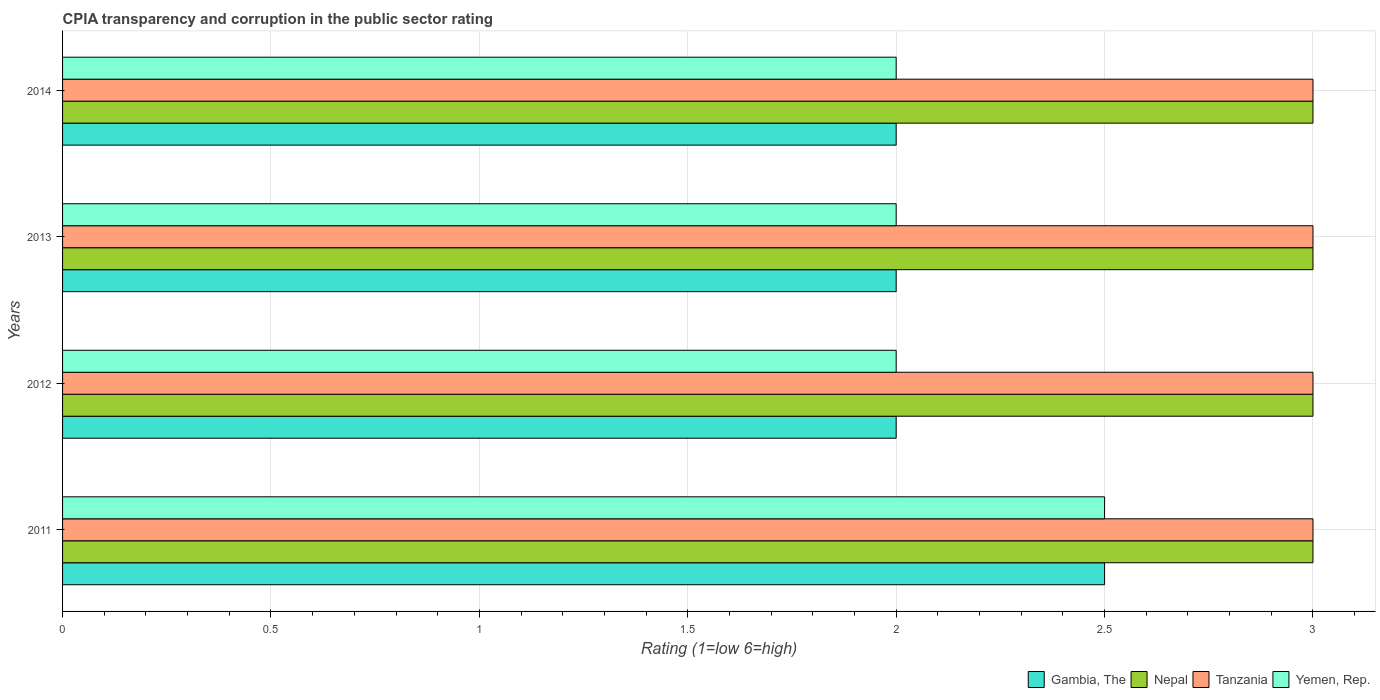How many different coloured bars are there?
Your answer should be compact. 4. Are the number of bars per tick equal to the number of legend labels?
Your answer should be very brief. Yes. How many bars are there on the 3rd tick from the bottom?
Your response must be concise. 4. What is the label of the 2nd group of bars from the top?
Make the answer very short. 2013. In how many cases, is the number of bars for a given year not equal to the number of legend labels?
Offer a terse response. 0. What is the CPIA rating in Yemen, Rep. in 2011?
Ensure brevity in your answer.  2.5. Across all years, what is the maximum CPIA rating in Gambia, The?
Offer a terse response. 2.5. Across all years, what is the minimum CPIA rating in Yemen, Rep.?
Make the answer very short. 2. In which year was the CPIA rating in Gambia, The maximum?
Offer a terse response. 2011. What is the total CPIA rating in Gambia, The in the graph?
Give a very brief answer. 8.5. What is the difference between the CPIA rating in Yemen, Rep. in 2013 and that in 2014?
Provide a short and direct response. 0. What is the difference between the CPIA rating in Yemen, Rep. in 2011 and the CPIA rating in Nepal in 2014?
Provide a succinct answer. -0.5. What is the average CPIA rating in Yemen, Rep. per year?
Your response must be concise. 2.12. In the year 2013, what is the difference between the CPIA rating in Tanzania and CPIA rating in Gambia, The?
Offer a very short reply. 1. What is the difference between the highest and the lowest CPIA rating in Gambia, The?
Make the answer very short. 0.5. Is the sum of the CPIA rating in Gambia, The in 2011 and 2012 greater than the maximum CPIA rating in Tanzania across all years?
Provide a short and direct response. Yes. Is it the case that in every year, the sum of the CPIA rating in Gambia, The and CPIA rating in Yemen, Rep. is greater than the sum of CPIA rating in Nepal and CPIA rating in Tanzania?
Keep it short and to the point. No. What does the 2nd bar from the top in 2011 represents?
Your response must be concise. Tanzania. What does the 4th bar from the bottom in 2013 represents?
Offer a terse response. Yemen, Rep. Are all the bars in the graph horizontal?
Keep it short and to the point. Yes. Does the graph contain any zero values?
Keep it short and to the point. No. Does the graph contain grids?
Make the answer very short. Yes. Where does the legend appear in the graph?
Offer a very short reply. Bottom right. How are the legend labels stacked?
Offer a terse response. Horizontal. What is the title of the graph?
Ensure brevity in your answer.  CPIA transparency and corruption in the public sector rating. What is the label or title of the X-axis?
Offer a terse response. Rating (1=low 6=high). What is the label or title of the Y-axis?
Keep it short and to the point. Years. What is the Rating (1=low 6=high) of Tanzania in 2011?
Your answer should be very brief. 3. What is the Rating (1=low 6=high) in Yemen, Rep. in 2011?
Your answer should be very brief. 2.5. What is the Rating (1=low 6=high) in Tanzania in 2012?
Your response must be concise. 3. What is the Rating (1=low 6=high) of Gambia, The in 2013?
Your response must be concise. 2. What is the Rating (1=low 6=high) of Nepal in 2013?
Your answer should be compact. 3. What is the Rating (1=low 6=high) in Tanzania in 2013?
Offer a terse response. 3. What is the Rating (1=low 6=high) in Yemen, Rep. in 2013?
Give a very brief answer. 2. What is the Rating (1=low 6=high) of Gambia, The in 2014?
Keep it short and to the point. 2. What is the Rating (1=low 6=high) of Nepal in 2014?
Keep it short and to the point. 3. What is the Rating (1=low 6=high) of Yemen, Rep. in 2014?
Make the answer very short. 2. Across all years, what is the maximum Rating (1=low 6=high) in Gambia, The?
Make the answer very short. 2.5. Across all years, what is the maximum Rating (1=low 6=high) in Tanzania?
Offer a very short reply. 3. Across all years, what is the minimum Rating (1=low 6=high) in Gambia, The?
Your response must be concise. 2. Across all years, what is the minimum Rating (1=low 6=high) in Nepal?
Your answer should be compact. 3. What is the total Rating (1=low 6=high) in Nepal in the graph?
Offer a very short reply. 12. What is the total Rating (1=low 6=high) of Tanzania in the graph?
Provide a succinct answer. 12. What is the total Rating (1=low 6=high) in Yemen, Rep. in the graph?
Provide a short and direct response. 8.5. What is the difference between the Rating (1=low 6=high) of Gambia, The in 2011 and that in 2012?
Provide a short and direct response. 0.5. What is the difference between the Rating (1=low 6=high) of Nepal in 2011 and that in 2012?
Make the answer very short. 0. What is the difference between the Rating (1=low 6=high) of Tanzania in 2011 and that in 2012?
Your response must be concise. 0. What is the difference between the Rating (1=low 6=high) of Nepal in 2011 and that in 2013?
Make the answer very short. 0. What is the difference between the Rating (1=low 6=high) in Tanzania in 2011 and that in 2014?
Offer a very short reply. 0. What is the difference between the Rating (1=low 6=high) in Gambia, The in 2012 and that in 2013?
Offer a terse response. 0. What is the difference between the Rating (1=low 6=high) in Gambia, The in 2012 and that in 2014?
Your answer should be compact. 0. What is the difference between the Rating (1=low 6=high) of Nepal in 2012 and that in 2014?
Make the answer very short. 0. What is the difference between the Rating (1=low 6=high) of Yemen, Rep. in 2012 and that in 2014?
Ensure brevity in your answer.  0. What is the difference between the Rating (1=low 6=high) of Gambia, The in 2011 and the Rating (1=low 6=high) of Yemen, Rep. in 2012?
Provide a short and direct response. 0.5. What is the difference between the Rating (1=low 6=high) in Nepal in 2011 and the Rating (1=low 6=high) in Yemen, Rep. in 2012?
Your response must be concise. 1. What is the difference between the Rating (1=low 6=high) of Tanzania in 2011 and the Rating (1=low 6=high) of Yemen, Rep. in 2012?
Offer a terse response. 1. What is the difference between the Rating (1=low 6=high) of Gambia, The in 2011 and the Rating (1=low 6=high) of Nepal in 2013?
Offer a terse response. -0.5. What is the difference between the Rating (1=low 6=high) in Gambia, The in 2011 and the Rating (1=low 6=high) in Yemen, Rep. in 2013?
Ensure brevity in your answer.  0.5. What is the difference between the Rating (1=low 6=high) in Gambia, The in 2011 and the Rating (1=low 6=high) in Tanzania in 2014?
Make the answer very short. -0.5. What is the difference between the Rating (1=low 6=high) in Gambia, The in 2011 and the Rating (1=low 6=high) in Yemen, Rep. in 2014?
Offer a terse response. 0.5. What is the difference between the Rating (1=low 6=high) of Tanzania in 2011 and the Rating (1=low 6=high) of Yemen, Rep. in 2014?
Keep it short and to the point. 1. What is the difference between the Rating (1=low 6=high) in Gambia, The in 2012 and the Rating (1=low 6=high) in Yemen, Rep. in 2013?
Offer a terse response. 0. What is the difference between the Rating (1=low 6=high) of Nepal in 2012 and the Rating (1=low 6=high) of Tanzania in 2013?
Make the answer very short. 0. What is the difference between the Rating (1=low 6=high) of Nepal in 2012 and the Rating (1=low 6=high) of Yemen, Rep. in 2013?
Your response must be concise. 1. What is the difference between the Rating (1=low 6=high) of Gambia, The in 2012 and the Rating (1=low 6=high) of Nepal in 2014?
Make the answer very short. -1. What is the difference between the Rating (1=low 6=high) of Gambia, The in 2012 and the Rating (1=low 6=high) of Tanzania in 2014?
Ensure brevity in your answer.  -1. What is the difference between the Rating (1=low 6=high) in Tanzania in 2012 and the Rating (1=low 6=high) in Yemen, Rep. in 2014?
Keep it short and to the point. 1. What is the difference between the Rating (1=low 6=high) in Gambia, The in 2013 and the Rating (1=low 6=high) in Nepal in 2014?
Your response must be concise. -1. What is the average Rating (1=low 6=high) in Gambia, The per year?
Provide a short and direct response. 2.12. What is the average Rating (1=low 6=high) in Tanzania per year?
Make the answer very short. 3. What is the average Rating (1=low 6=high) of Yemen, Rep. per year?
Offer a terse response. 2.12. In the year 2011, what is the difference between the Rating (1=low 6=high) of Gambia, The and Rating (1=low 6=high) of Tanzania?
Offer a terse response. -0.5. In the year 2011, what is the difference between the Rating (1=low 6=high) of Tanzania and Rating (1=low 6=high) of Yemen, Rep.?
Provide a succinct answer. 0.5. In the year 2012, what is the difference between the Rating (1=low 6=high) of Gambia, The and Rating (1=low 6=high) of Nepal?
Provide a succinct answer. -1. In the year 2012, what is the difference between the Rating (1=low 6=high) in Gambia, The and Rating (1=low 6=high) in Tanzania?
Offer a terse response. -1. In the year 2012, what is the difference between the Rating (1=low 6=high) of Gambia, The and Rating (1=low 6=high) of Yemen, Rep.?
Offer a very short reply. 0. In the year 2012, what is the difference between the Rating (1=low 6=high) of Nepal and Rating (1=low 6=high) of Tanzania?
Keep it short and to the point. 0. In the year 2012, what is the difference between the Rating (1=low 6=high) in Nepal and Rating (1=low 6=high) in Yemen, Rep.?
Ensure brevity in your answer.  1. In the year 2012, what is the difference between the Rating (1=low 6=high) in Tanzania and Rating (1=low 6=high) in Yemen, Rep.?
Provide a succinct answer. 1. In the year 2013, what is the difference between the Rating (1=low 6=high) in Gambia, The and Rating (1=low 6=high) in Nepal?
Your response must be concise. -1. In the year 2013, what is the difference between the Rating (1=low 6=high) of Gambia, The and Rating (1=low 6=high) of Tanzania?
Keep it short and to the point. -1. In the year 2013, what is the difference between the Rating (1=low 6=high) of Gambia, The and Rating (1=low 6=high) of Yemen, Rep.?
Make the answer very short. 0. In the year 2013, what is the difference between the Rating (1=low 6=high) of Nepal and Rating (1=low 6=high) of Yemen, Rep.?
Give a very brief answer. 1. In the year 2014, what is the difference between the Rating (1=low 6=high) in Gambia, The and Rating (1=low 6=high) in Nepal?
Make the answer very short. -1. In the year 2014, what is the difference between the Rating (1=low 6=high) of Gambia, The and Rating (1=low 6=high) of Tanzania?
Your answer should be very brief. -1. In the year 2014, what is the difference between the Rating (1=low 6=high) of Gambia, The and Rating (1=low 6=high) of Yemen, Rep.?
Offer a terse response. 0. In the year 2014, what is the difference between the Rating (1=low 6=high) of Nepal and Rating (1=low 6=high) of Tanzania?
Your response must be concise. 0. In the year 2014, what is the difference between the Rating (1=low 6=high) of Nepal and Rating (1=low 6=high) of Yemen, Rep.?
Provide a short and direct response. 1. What is the ratio of the Rating (1=low 6=high) in Gambia, The in 2011 to that in 2012?
Your answer should be compact. 1.25. What is the ratio of the Rating (1=low 6=high) in Tanzania in 2011 to that in 2012?
Ensure brevity in your answer.  1. What is the ratio of the Rating (1=low 6=high) of Yemen, Rep. in 2011 to that in 2013?
Your answer should be very brief. 1.25. What is the ratio of the Rating (1=low 6=high) of Nepal in 2011 to that in 2014?
Provide a short and direct response. 1. What is the ratio of the Rating (1=low 6=high) in Tanzania in 2011 to that in 2014?
Your response must be concise. 1. What is the ratio of the Rating (1=low 6=high) in Gambia, The in 2012 to that in 2013?
Your response must be concise. 1. What is the ratio of the Rating (1=low 6=high) in Nepal in 2012 to that in 2014?
Your response must be concise. 1. What is the ratio of the Rating (1=low 6=high) of Tanzania in 2012 to that in 2014?
Provide a short and direct response. 1. What is the difference between the highest and the second highest Rating (1=low 6=high) of Gambia, The?
Keep it short and to the point. 0.5. What is the difference between the highest and the second highest Rating (1=low 6=high) in Tanzania?
Provide a succinct answer. 0. What is the difference between the highest and the second highest Rating (1=low 6=high) of Yemen, Rep.?
Your answer should be compact. 0.5. What is the difference between the highest and the lowest Rating (1=low 6=high) in Yemen, Rep.?
Offer a very short reply. 0.5. 